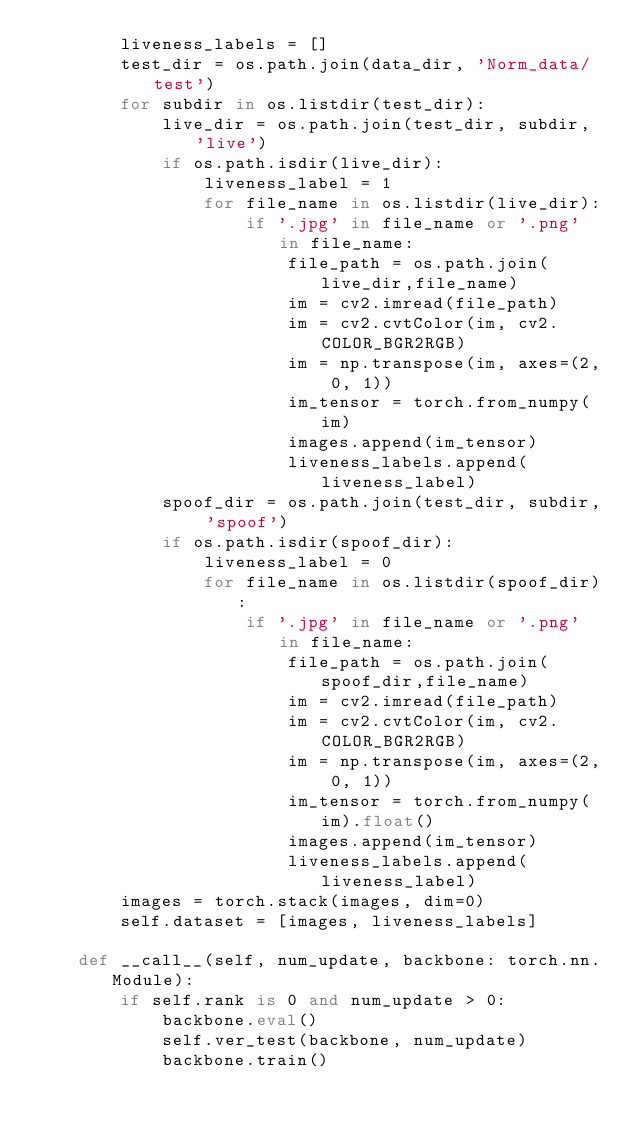<code> <loc_0><loc_0><loc_500><loc_500><_Python_>        liveness_labels = []
        test_dir = os.path.join(data_dir, 'Norm_data/test')
        for subdir in os.listdir(test_dir):
            live_dir = os.path.join(test_dir, subdir, 'live')
            if os.path.isdir(live_dir):
                liveness_label = 1
                for file_name in os.listdir(live_dir):
                    if '.jpg' in file_name or '.png' in file_name:
                        file_path = os.path.join(live_dir,file_name)
                        im = cv2.imread(file_path)
                        im = cv2.cvtColor(im, cv2.COLOR_BGR2RGB)
                        im = np.transpose(im, axes=(2, 0, 1))
                        im_tensor = torch.from_numpy(im)
                        images.append(im_tensor)
                        liveness_labels.append(liveness_label)
            spoof_dir = os.path.join(test_dir, subdir, 'spoof')
            if os.path.isdir(spoof_dir):
                liveness_label = 0
                for file_name in os.listdir(spoof_dir):
                    if '.jpg' in file_name or '.png' in file_name:
                        file_path = os.path.join(spoof_dir,file_name)
                        im = cv2.imread(file_path)
                        im = cv2.cvtColor(im, cv2.COLOR_BGR2RGB)
                        im = np.transpose(im, axes=(2, 0, 1))
                        im_tensor = torch.from_numpy(im).float()
                        images.append(im_tensor)
                        liveness_labels.append(liveness_label)
        images = torch.stack(images, dim=0)
        self.dataset = [images, liveness_labels]

    def __call__(self, num_update, backbone: torch.nn.Module):
        if self.rank is 0 and num_update > 0:
            backbone.eval()
            self.ver_test(backbone, num_update)
            backbone.train()</code> 